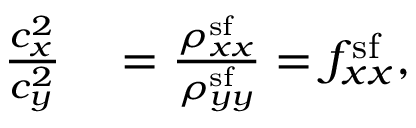<formula> <loc_0><loc_0><loc_500><loc_500>\begin{array} { r l } { \frac { c _ { x } ^ { 2 } } { c _ { y } ^ { 2 } } } & = \frac { \rho _ { x x } ^ { s f } } { \rho _ { y y } ^ { s f } } = f _ { x x } ^ { s f } , } \end{array}</formula> 